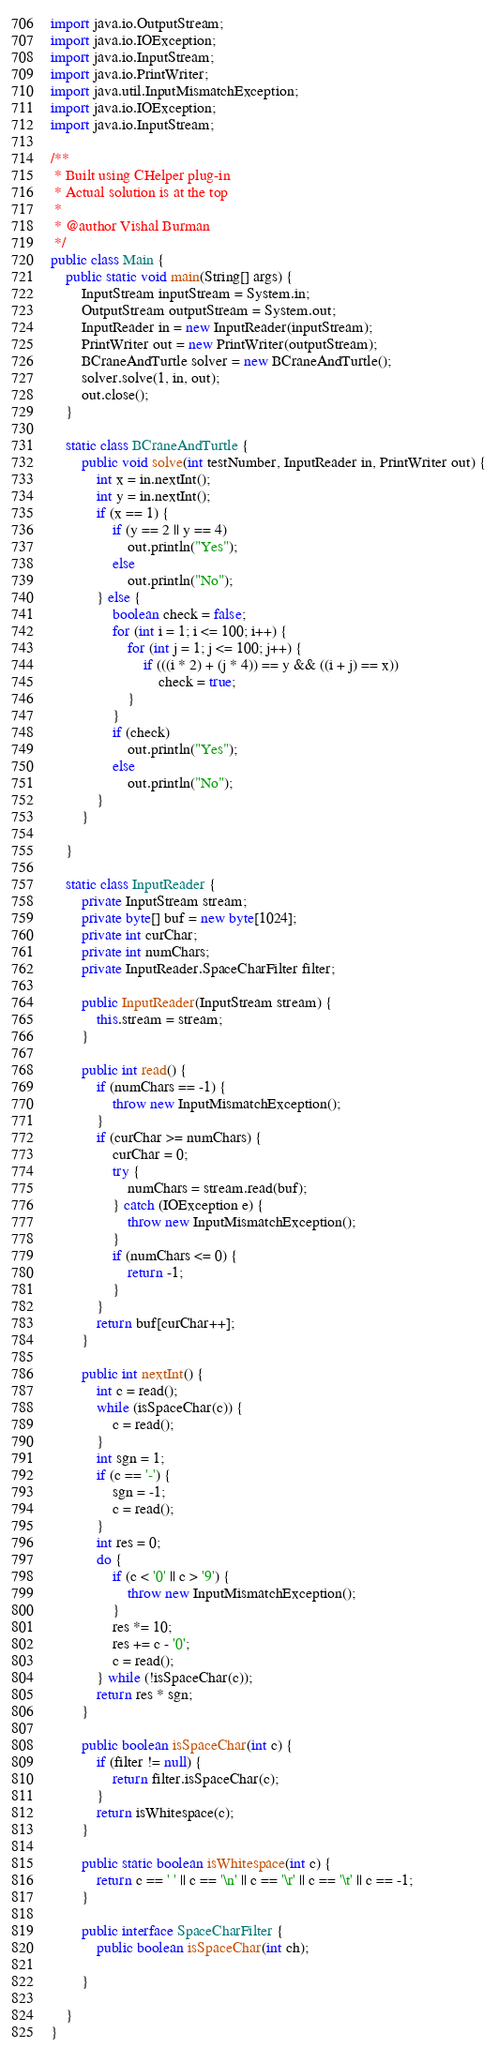Convert code to text. <code><loc_0><loc_0><loc_500><loc_500><_Java_>import java.io.OutputStream;
import java.io.IOException;
import java.io.InputStream;
import java.io.PrintWriter;
import java.util.InputMismatchException;
import java.io.IOException;
import java.io.InputStream;

/**
 * Built using CHelper plug-in
 * Actual solution is at the top
 *
 * @author Vishal Burman
 */
public class Main {
    public static void main(String[] args) {
        InputStream inputStream = System.in;
        OutputStream outputStream = System.out;
        InputReader in = new InputReader(inputStream);
        PrintWriter out = new PrintWriter(outputStream);
        BCraneAndTurtle solver = new BCraneAndTurtle();
        solver.solve(1, in, out);
        out.close();
    }

    static class BCraneAndTurtle {
        public void solve(int testNumber, InputReader in, PrintWriter out) {
            int x = in.nextInt();
            int y = in.nextInt();
            if (x == 1) {
                if (y == 2 || y == 4)
                    out.println("Yes");
                else
                    out.println("No");
            } else {
                boolean check = false;
                for (int i = 1; i <= 100; i++) {
                    for (int j = 1; j <= 100; j++) {
                        if (((i * 2) + (j * 4)) == y && ((i + j) == x))
                            check = true;
                    }
                }
                if (check)
                    out.println("Yes");
                else
                    out.println("No");
            }
        }

    }

    static class InputReader {
        private InputStream stream;
        private byte[] buf = new byte[1024];
        private int curChar;
        private int numChars;
        private InputReader.SpaceCharFilter filter;

        public InputReader(InputStream stream) {
            this.stream = stream;
        }

        public int read() {
            if (numChars == -1) {
                throw new InputMismatchException();
            }
            if (curChar >= numChars) {
                curChar = 0;
                try {
                    numChars = stream.read(buf);
                } catch (IOException e) {
                    throw new InputMismatchException();
                }
                if (numChars <= 0) {
                    return -1;
                }
            }
            return buf[curChar++];
        }

        public int nextInt() {
            int c = read();
            while (isSpaceChar(c)) {
                c = read();
            }
            int sgn = 1;
            if (c == '-') {
                sgn = -1;
                c = read();
            }
            int res = 0;
            do {
                if (c < '0' || c > '9') {
                    throw new InputMismatchException();
                }
                res *= 10;
                res += c - '0';
                c = read();
            } while (!isSpaceChar(c));
            return res * sgn;
        }

        public boolean isSpaceChar(int c) {
            if (filter != null) {
                return filter.isSpaceChar(c);
            }
            return isWhitespace(c);
        }

        public static boolean isWhitespace(int c) {
            return c == ' ' || c == '\n' || c == '\r' || c == '\t' || c == -1;
        }

        public interface SpaceCharFilter {
            public boolean isSpaceChar(int ch);

        }

    }
}

</code> 